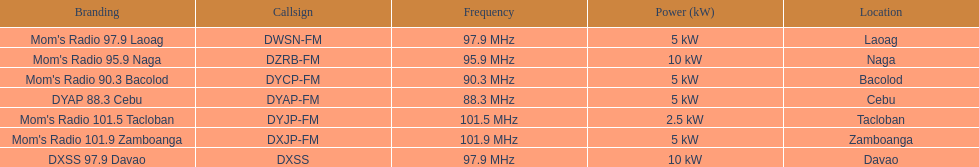What is the radio with the most mhz? Mom's Radio 101.9 Zamboanga. Could you help me parse every detail presented in this table? {'header': ['Branding', 'Callsign', 'Frequency', 'Power (kW)', 'Location'], 'rows': [["Mom's Radio 97.9 Laoag", 'DWSN-FM', '97.9\xa0MHz', '5\xa0kW', 'Laoag'], ["Mom's Radio 95.9 Naga", 'DZRB-FM', '95.9\xa0MHz', '10\xa0kW', 'Naga'], ["Mom's Radio 90.3 Bacolod", 'DYCP-FM', '90.3\xa0MHz', '5\xa0kW', 'Bacolod'], ['DYAP 88.3 Cebu', 'DYAP-FM', '88.3\xa0MHz', '5\xa0kW', 'Cebu'], ["Mom's Radio 101.5 Tacloban", 'DYJP-FM', '101.5\xa0MHz', '2.5\xa0kW', 'Tacloban'], ["Mom's Radio 101.9 Zamboanga", 'DXJP-FM', '101.9\xa0MHz', '5\xa0kW', 'Zamboanga'], ['DXSS 97.9 Davao', 'DXSS', '97.9\xa0MHz', '10\xa0kW', 'Davao']]} 